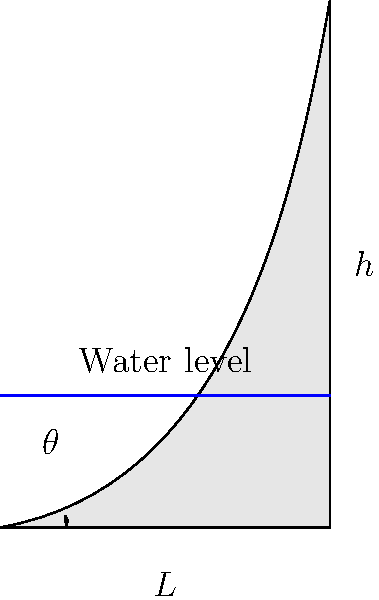In ancient Egypt, an Archimedes screw was used for irrigation. The screw has a length $L$ of 5 meters and raises water to a height $h$ of 2 meters. If the screw makes one complete revolution to raise the water, what is the mechanical advantage of this system? Assume the screw's angle of inclination is $\theta$. To solve this problem, we'll follow these steps:

1) First, recall that mechanical advantage (MA) is the ratio of the output force to the input force. In this case, it's the ratio of the weight of water lifted to the force applied along the screw's length.

2) The mechanical advantage of an inclined plane (which the Archimedes screw essentially is) is given by:

   $$ MA = \frac{L}{h} $$

   where $L$ is the length of the plane and $h$ is the vertical height.

3) We're given:
   $L = 5$ meters
   $h = 2$ meters

4) Simply plugging these values into our equation:

   $$ MA = \frac{5 \text{ m}}{2 \text{ m}} = 2.5 $$

5) This means that for every unit of force applied to the screw, 2.5 units of weight can be lifted.

6) Note: We can also calculate the angle of inclination $\theta$, though it's not necessary for finding MA:

   $$ \sin \theta = \frac{h}{L} = \frac{2}{5} = 0.4 $$
   $$ \theta = \arcsin(0.4) \approx 23.6° $$

This angle represents the efficiency of the system. A smaller angle would increase the mechanical advantage but require more revolutions to lift the water.
Answer: 2.5 